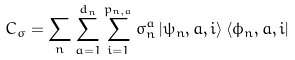Convert formula to latex. <formula><loc_0><loc_0><loc_500><loc_500>C _ { \sigma } = \sum _ { n } \sum _ { a = 1 } ^ { d _ { n } } \sum _ { i = 1 } ^ { p _ { n , a } } \sigma _ { n } ^ { a } \left | \psi _ { n } , a , i \right \rangle \left \langle \phi _ { n } , a , i \right |</formula> 